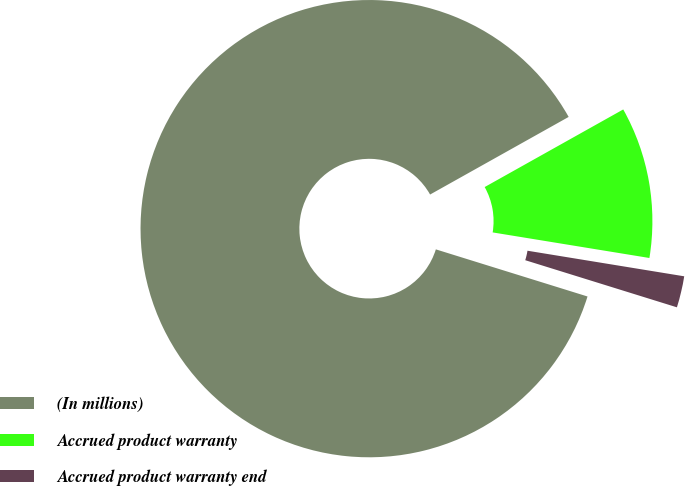Convert chart. <chart><loc_0><loc_0><loc_500><loc_500><pie_chart><fcel>(In millions)<fcel>Accrued product warranty<fcel>Accrued product warranty end<nl><fcel>87.08%<fcel>10.7%<fcel>2.22%<nl></chart> 